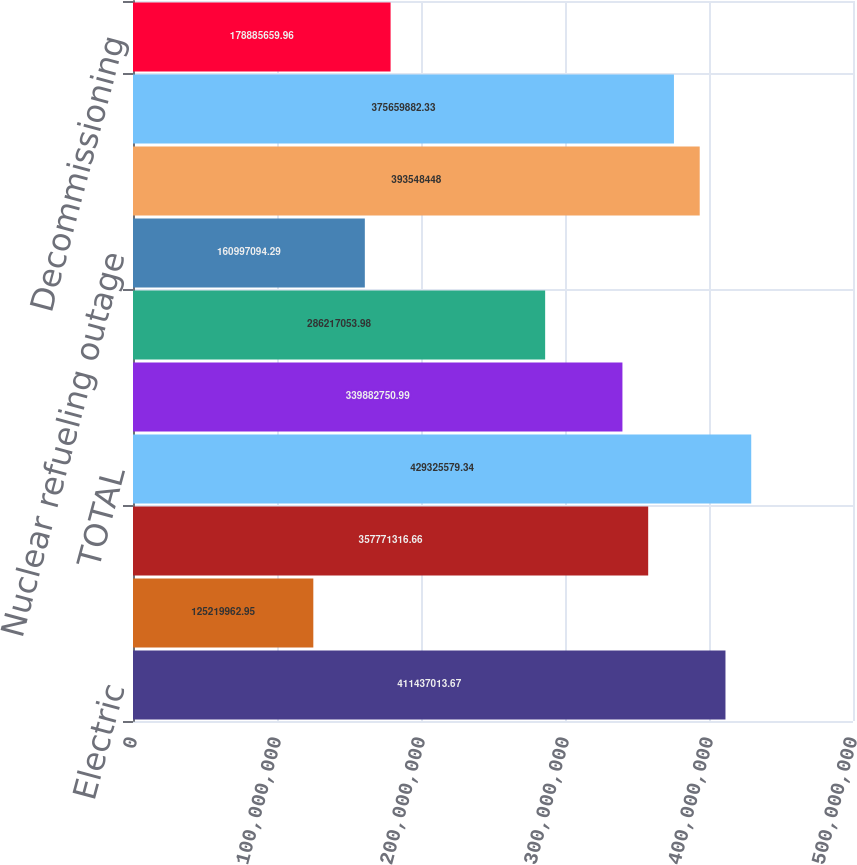<chart> <loc_0><loc_0><loc_500><loc_500><bar_chart><fcel>Electric<fcel>Natural gas<fcel>Competitive businesses<fcel>TOTAL<fcel>Fuel fuel-related expenses and<fcel>Purchased power<fcel>Nuclear refueling outage<fcel>Other operation and<fcel>Asset write-offs impairments<fcel>Decommissioning<nl><fcel>4.11437e+08<fcel>1.2522e+08<fcel>3.57771e+08<fcel>4.29326e+08<fcel>3.39883e+08<fcel>2.86217e+08<fcel>1.60997e+08<fcel>3.93548e+08<fcel>3.7566e+08<fcel>1.78886e+08<nl></chart> 